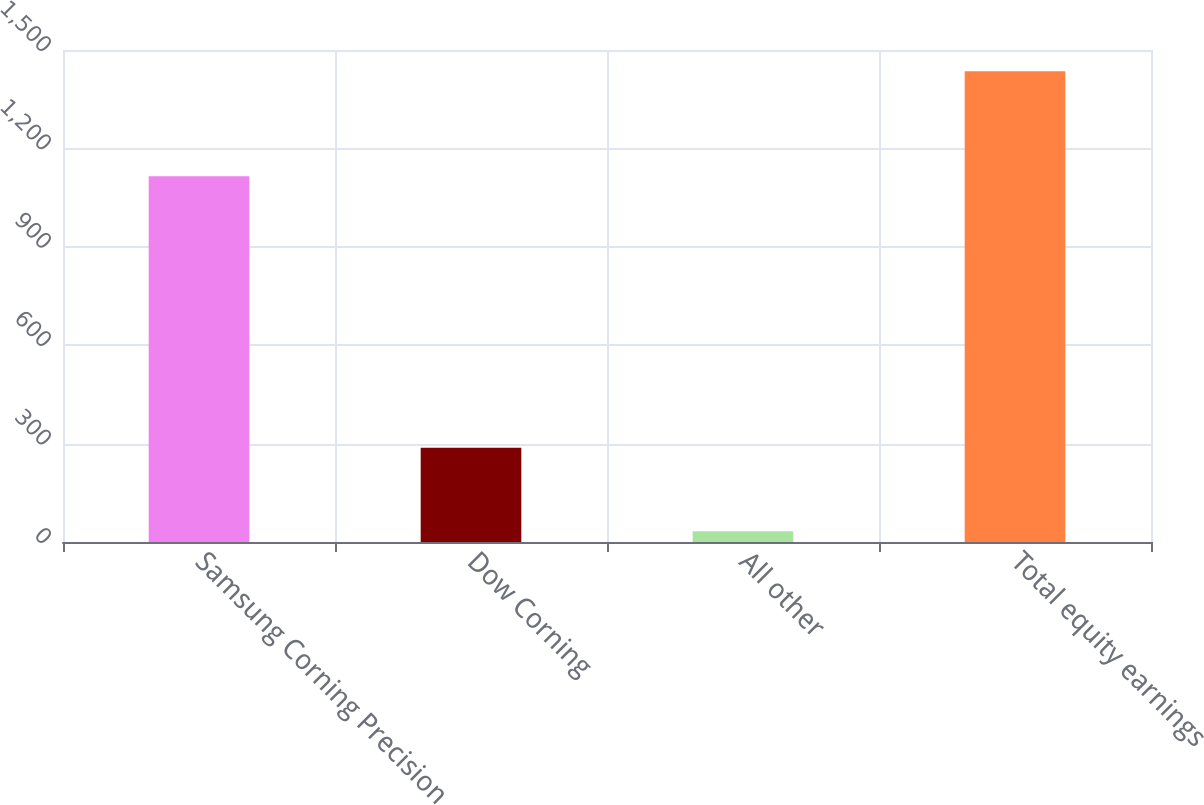Convert chart to OTSL. <chart><loc_0><loc_0><loc_500><loc_500><bar_chart><fcel>Samsung Corning Precision<fcel>Dow Corning<fcel>All other<fcel>Total equity earnings<nl><fcel>1115<fcel>287<fcel>33<fcel>1435<nl></chart> 